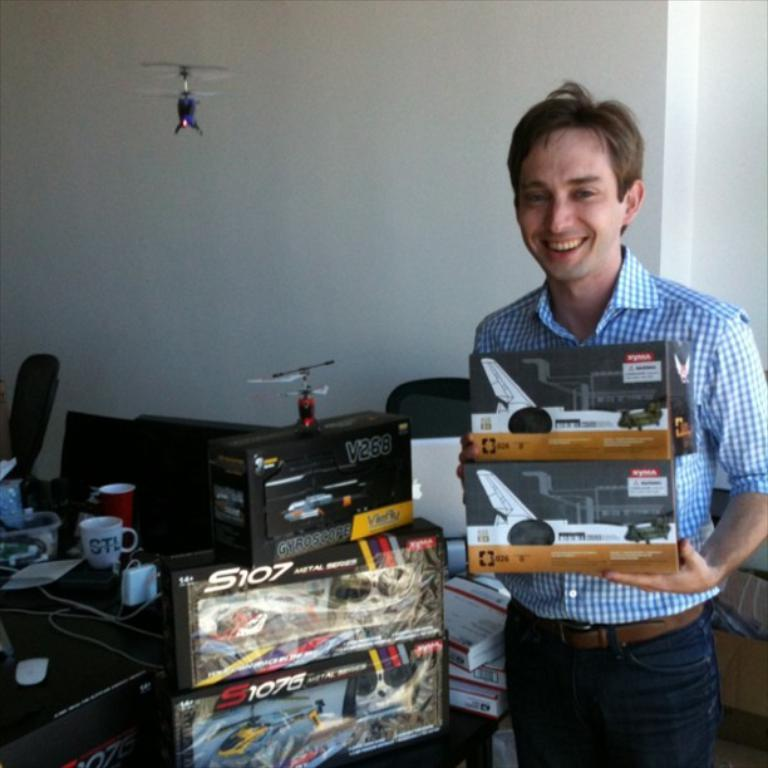<image>
Create a compact narrative representing the image presented. a man with toy planes next to a v268 box 